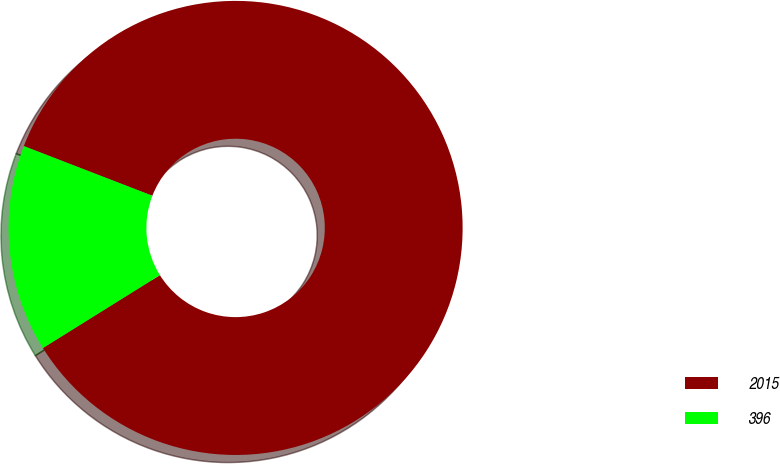Convert chart to OTSL. <chart><loc_0><loc_0><loc_500><loc_500><pie_chart><fcel>2015<fcel>396<nl><fcel>85.26%<fcel>14.74%<nl></chart> 